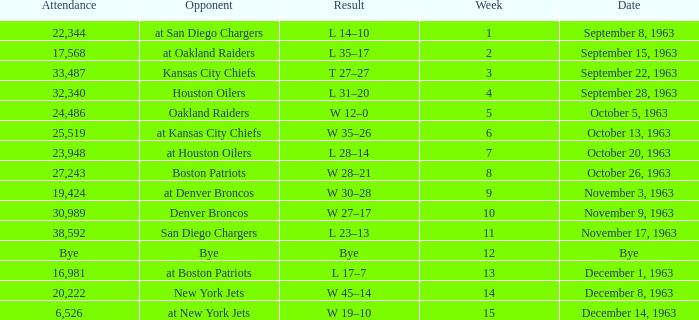Which competitor has a score of 14-10? At san diego chargers. 